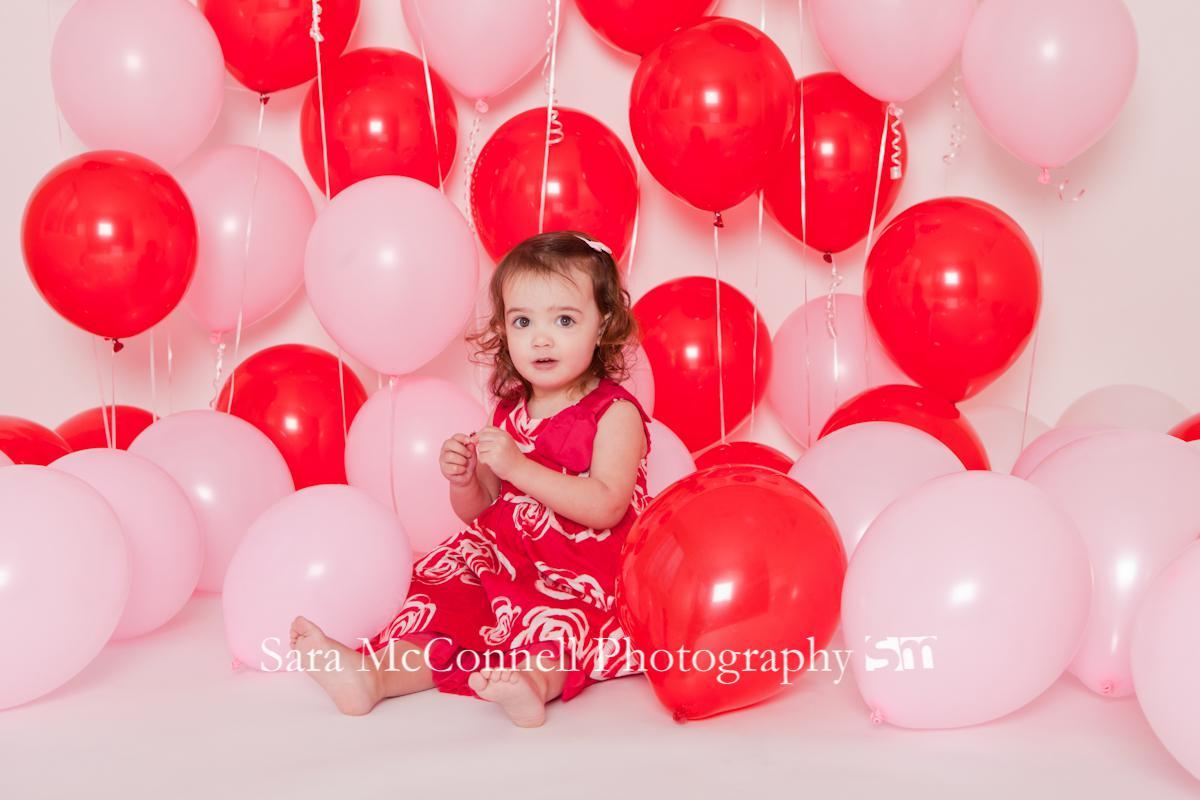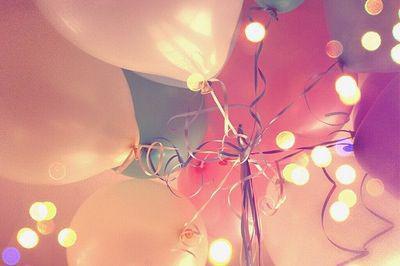The first image is the image on the left, the second image is the image on the right. For the images displayed, is the sentence "In one of the images a seated child is near many balloons." factually correct? Answer yes or no. Yes. The first image is the image on the left, the second image is the image on the right. For the images shown, is this caption "There is a group of pink balloons together with trees in the background in the right image." true? Answer yes or no. No. 